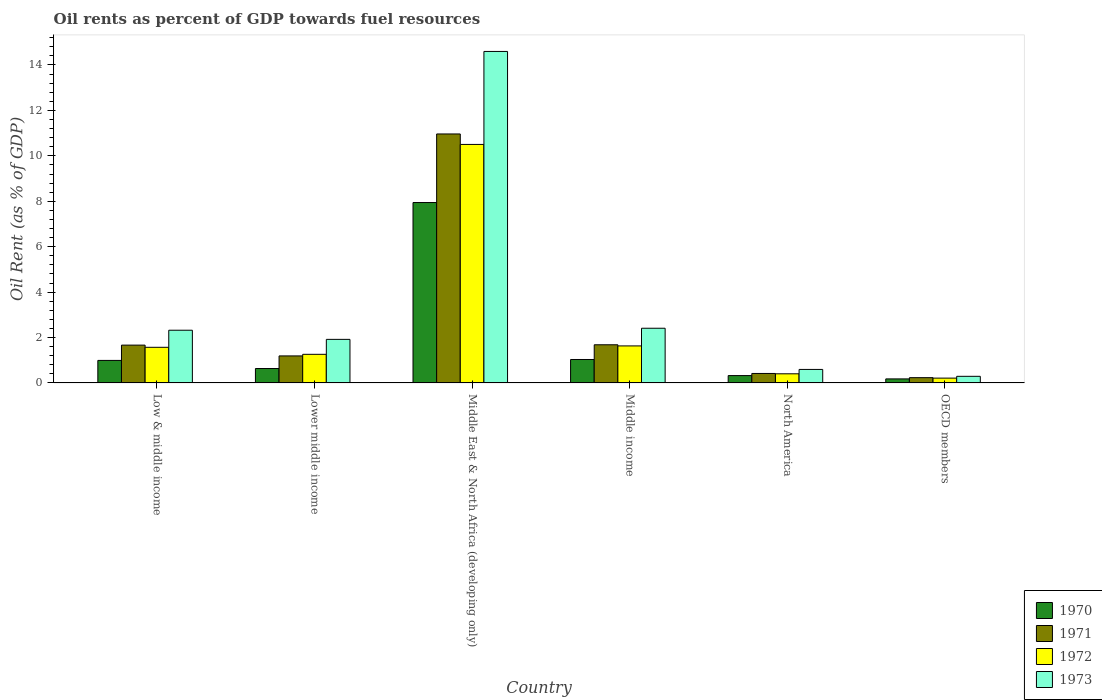How many different coloured bars are there?
Provide a short and direct response. 4. How many groups of bars are there?
Ensure brevity in your answer.  6. Are the number of bars on each tick of the X-axis equal?
Make the answer very short. Yes. How many bars are there on the 6th tick from the right?
Your answer should be very brief. 4. In how many cases, is the number of bars for a given country not equal to the number of legend labels?
Make the answer very short. 0. What is the oil rent in 1972 in Lower middle income?
Give a very brief answer. 1.26. Across all countries, what is the maximum oil rent in 1973?
Ensure brevity in your answer.  14.6. Across all countries, what is the minimum oil rent in 1972?
Offer a very short reply. 0.21. In which country was the oil rent in 1971 maximum?
Ensure brevity in your answer.  Middle East & North Africa (developing only). In which country was the oil rent in 1972 minimum?
Your answer should be compact. OECD members. What is the total oil rent in 1973 in the graph?
Keep it short and to the point. 22.13. What is the difference between the oil rent in 1972 in Low & middle income and that in Lower middle income?
Offer a terse response. 0.31. What is the difference between the oil rent in 1973 in Middle East & North Africa (developing only) and the oil rent in 1972 in OECD members?
Give a very brief answer. 14.38. What is the average oil rent in 1972 per country?
Your response must be concise. 2.6. What is the difference between the oil rent of/in 1973 and oil rent of/in 1972 in Middle East & North Africa (developing only)?
Offer a very short reply. 4.09. In how many countries, is the oil rent in 1972 greater than 14 %?
Provide a succinct answer. 0. What is the ratio of the oil rent in 1970 in Middle income to that in North America?
Your answer should be compact. 3.19. Is the oil rent in 1973 in Low & middle income less than that in OECD members?
Provide a short and direct response. No. What is the difference between the highest and the second highest oil rent in 1970?
Ensure brevity in your answer.  -0.04. What is the difference between the highest and the lowest oil rent in 1972?
Provide a short and direct response. 10.29. In how many countries, is the oil rent in 1972 greater than the average oil rent in 1972 taken over all countries?
Your answer should be very brief. 1. Is the sum of the oil rent in 1971 in Low & middle income and Lower middle income greater than the maximum oil rent in 1970 across all countries?
Provide a short and direct response. No. What does the 1st bar from the left in North America represents?
Ensure brevity in your answer.  1970. What does the 2nd bar from the right in Low & middle income represents?
Give a very brief answer. 1972. How many countries are there in the graph?
Give a very brief answer. 6. What is the difference between two consecutive major ticks on the Y-axis?
Keep it short and to the point. 2. Does the graph contain any zero values?
Make the answer very short. No. What is the title of the graph?
Provide a short and direct response. Oil rents as percent of GDP towards fuel resources. Does "1975" appear as one of the legend labels in the graph?
Offer a very short reply. No. What is the label or title of the X-axis?
Provide a succinct answer. Country. What is the label or title of the Y-axis?
Offer a very short reply. Oil Rent (as % of GDP). What is the Oil Rent (as % of GDP) in 1970 in Low & middle income?
Make the answer very short. 0.99. What is the Oil Rent (as % of GDP) of 1971 in Low & middle income?
Offer a very short reply. 1.67. What is the Oil Rent (as % of GDP) in 1972 in Low & middle income?
Offer a very short reply. 1.57. What is the Oil Rent (as % of GDP) of 1973 in Low & middle income?
Provide a short and direct response. 2.32. What is the Oil Rent (as % of GDP) in 1970 in Lower middle income?
Provide a short and direct response. 0.63. What is the Oil Rent (as % of GDP) of 1971 in Lower middle income?
Your response must be concise. 1.19. What is the Oil Rent (as % of GDP) in 1972 in Lower middle income?
Provide a short and direct response. 1.26. What is the Oil Rent (as % of GDP) in 1973 in Lower middle income?
Ensure brevity in your answer.  1.92. What is the Oil Rent (as % of GDP) in 1970 in Middle East & North Africa (developing only)?
Make the answer very short. 7.94. What is the Oil Rent (as % of GDP) in 1971 in Middle East & North Africa (developing only)?
Ensure brevity in your answer.  10.96. What is the Oil Rent (as % of GDP) in 1972 in Middle East & North Africa (developing only)?
Your answer should be very brief. 10.5. What is the Oil Rent (as % of GDP) of 1973 in Middle East & North Africa (developing only)?
Give a very brief answer. 14.6. What is the Oil Rent (as % of GDP) in 1970 in Middle income?
Ensure brevity in your answer.  1.03. What is the Oil Rent (as % of GDP) of 1971 in Middle income?
Keep it short and to the point. 1.68. What is the Oil Rent (as % of GDP) in 1972 in Middle income?
Ensure brevity in your answer.  1.63. What is the Oil Rent (as % of GDP) of 1973 in Middle income?
Offer a terse response. 2.41. What is the Oil Rent (as % of GDP) of 1970 in North America?
Make the answer very short. 0.32. What is the Oil Rent (as % of GDP) in 1971 in North America?
Provide a succinct answer. 0.42. What is the Oil Rent (as % of GDP) of 1972 in North America?
Make the answer very short. 0.4. What is the Oil Rent (as % of GDP) in 1973 in North America?
Offer a terse response. 0.6. What is the Oil Rent (as % of GDP) in 1970 in OECD members?
Your response must be concise. 0.18. What is the Oil Rent (as % of GDP) in 1971 in OECD members?
Your answer should be very brief. 0.23. What is the Oil Rent (as % of GDP) of 1972 in OECD members?
Make the answer very short. 0.21. What is the Oil Rent (as % of GDP) in 1973 in OECD members?
Give a very brief answer. 0.29. Across all countries, what is the maximum Oil Rent (as % of GDP) in 1970?
Offer a terse response. 7.94. Across all countries, what is the maximum Oil Rent (as % of GDP) in 1971?
Keep it short and to the point. 10.96. Across all countries, what is the maximum Oil Rent (as % of GDP) in 1972?
Your answer should be very brief. 10.5. Across all countries, what is the maximum Oil Rent (as % of GDP) in 1973?
Your response must be concise. 14.6. Across all countries, what is the minimum Oil Rent (as % of GDP) of 1970?
Provide a short and direct response. 0.18. Across all countries, what is the minimum Oil Rent (as % of GDP) of 1971?
Give a very brief answer. 0.23. Across all countries, what is the minimum Oil Rent (as % of GDP) of 1972?
Keep it short and to the point. 0.21. Across all countries, what is the minimum Oil Rent (as % of GDP) of 1973?
Provide a short and direct response. 0.29. What is the total Oil Rent (as % of GDP) in 1970 in the graph?
Provide a succinct answer. 11.1. What is the total Oil Rent (as % of GDP) of 1971 in the graph?
Provide a succinct answer. 16.15. What is the total Oil Rent (as % of GDP) in 1972 in the graph?
Ensure brevity in your answer.  15.58. What is the total Oil Rent (as % of GDP) of 1973 in the graph?
Give a very brief answer. 22.13. What is the difference between the Oil Rent (as % of GDP) in 1970 in Low & middle income and that in Lower middle income?
Your answer should be very brief. 0.36. What is the difference between the Oil Rent (as % of GDP) in 1971 in Low & middle income and that in Lower middle income?
Your answer should be compact. 0.48. What is the difference between the Oil Rent (as % of GDP) of 1972 in Low & middle income and that in Lower middle income?
Offer a terse response. 0.31. What is the difference between the Oil Rent (as % of GDP) of 1973 in Low & middle income and that in Lower middle income?
Your answer should be very brief. 0.4. What is the difference between the Oil Rent (as % of GDP) of 1970 in Low & middle income and that in Middle East & North Africa (developing only)?
Offer a terse response. -6.95. What is the difference between the Oil Rent (as % of GDP) of 1971 in Low & middle income and that in Middle East & North Africa (developing only)?
Keep it short and to the point. -9.3. What is the difference between the Oil Rent (as % of GDP) in 1972 in Low & middle income and that in Middle East & North Africa (developing only)?
Your response must be concise. -8.93. What is the difference between the Oil Rent (as % of GDP) of 1973 in Low & middle income and that in Middle East & North Africa (developing only)?
Give a very brief answer. -12.28. What is the difference between the Oil Rent (as % of GDP) in 1970 in Low & middle income and that in Middle income?
Provide a short and direct response. -0.04. What is the difference between the Oil Rent (as % of GDP) in 1971 in Low & middle income and that in Middle income?
Provide a succinct answer. -0.01. What is the difference between the Oil Rent (as % of GDP) in 1972 in Low & middle income and that in Middle income?
Make the answer very short. -0.06. What is the difference between the Oil Rent (as % of GDP) in 1973 in Low & middle income and that in Middle income?
Provide a short and direct response. -0.09. What is the difference between the Oil Rent (as % of GDP) of 1970 in Low & middle income and that in North America?
Your response must be concise. 0.67. What is the difference between the Oil Rent (as % of GDP) of 1971 in Low & middle income and that in North America?
Keep it short and to the point. 1.25. What is the difference between the Oil Rent (as % of GDP) of 1972 in Low & middle income and that in North America?
Give a very brief answer. 1.17. What is the difference between the Oil Rent (as % of GDP) of 1973 in Low & middle income and that in North America?
Offer a terse response. 1.73. What is the difference between the Oil Rent (as % of GDP) in 1970 in Low & middle income and that in OECD members?
Offer a terse response. 0.81. What is the difference between the Oil Rent (as % of GDP) of 1971 in Low & middle income and that in OECD members?
Make the answer very short. 1.43. What is the difference between the Oil Rent (as % of GDP) in 1972 in Low & middle income and that in OECD members?
Provide a short and direct response. 1.36. What is the difference between the Oil Rent (as % of GDP) in 1973 in Low & middle income and that in OECD members?
Ensure brevity in your answer.  2.03. What is the difference between the Oil Rent (as % of GDP) in 1970 in Lower middle income and that in Middle East & North Africa (developing only)?
Your response must be concise. -7.31. What is the difference between the Oil Rent (as % of GDP) in 1971 in Lower middle income and that in Middle East & North Africa (developing only)?
Give a very brief answer. -9.77. What is the difference between the Oil Rent (as % of GDP) of 1972 in Lower middle income and that in Middle East & North Africa (developing only)?
Provide a short and direct response. -9.24. What is the difference between the Oil Rent (as % of GDP) of 1973 in Lower middle income and that in Middle East & North Africa (developing only)?
Offer a terse response. -12.68. What is the difference between the Oil Rent (as % of GDP) in 1970 in Lower middle income and that in Middle income?
Provide a succinct answer. -0.4. What is the difference between the Oil Rent (as % of GDP) in 1971 in Lower middle income and that in Middle income?
Ensure brevity in your answer.  -0.49. What is the difference between the Oil Rent (as % of GDP) of 1972 in Lower middle income and that in Middle income?
Ensure brevity in your answer.  -0.37. What is the difference between the Oil Rent (as % of GDP) in 1973 in Lower middle income and that in Middle income?
Offer a terse response. -0.49. What is the difference between the Oil Rent (as % of GDP) in 1970 in Lower middle income and that in North America?
Your answer should be compact. 0.31. What is the difference between the Oil Rent (as % of GDP) in 1971 in Lower middle income and that in North America?
Ensure brevity in your answer.  0.77. What is the difference between the Oil Rent (as % of GDP) in 1972 in Lower middle income and that in North America?
Your answer should be compact. 0.86. What is the difference between the Oil Rent (as % of GDP) of 1973 in Lower middle income and that in North America?
Give a very brief answer. 1.32. What is the difference between the Oil Rent (as % of GDP) of 1970 in Lower middle income and that in OECD members?
Give a very brief answer. 0.46. What is the difference between the Oil Rent (as % of GDP) in 1971 in Lower middle income and that in OECD members?
Give a very brief answer. 0.96. What is the difference between the Oil Rent (as % of GDP) in 1972 in Lower middle income and that in OECD members?
Keep it short and to the point. 1.05. What is the difference between the Oil Rent (as % of GDP) in 1973 in Lower middle income and that in OECD members?
Your answer should be compact. 1.63. What is the difference between the Oil Rent (as % of GDP) of 1970 in Middle East & North Africa (developing only) and that in Middle income?
Your answer should be very brief. 6.91. What is the difference between the Oil Rent (as % of GDP) of 1971 in Middle East & North Africa (developing only) and that in Middle income?
Provide a succinct answer. 9.28. What is the difference between the Oil Rent (as % of GDP) of 1972 in Middle East & North Africa (developing only) and that in Middle income?
Your answer should be compact. 8.87. What is the difference between the Oil Rent (as % of GDP) in 1973 in Middle East & North Africa (developing only) and that in Middle income?
Offer a terse response. 12.19. What is the difference between the Oil Rent (as % of GDP) in 1970 in Middle East & North Africa (developing only) and that in North America?
Offer a very short reply. 7.62. What is the difference between the Oil Rent (as % of GDP) in 1971 in Middle East & North Africa (developing only) and that in North America?
Offer a very short reply. 10.55. What is the difference between the Oil Rent (as % of GDP) in 1972 in Middle East & North Africa (developing only) and that in North America?
Ensure brevity in your answer.  10.1. What is the difference between the Oil Rent (as % of GDP) in 1973 in Middle East & North Africa (developing only) and that in North America?
Ensure brevity in your answer.  14. What is the difference between the Oil Rent (as % of GDP) in 1970 in Middle East & North Africa (developing only) and that in OECD members?
Your answer should be very brief. 7.77. What is the difference between the Oil Rent (as % of GDP) of 1971 in Middle East & North Africa (developing only) and that in OECD members?
Offer a very short reply. 10.73. What is the difference between the Oil Rent (as % of GDP) of 1972 in Middle East & North Africa (developing only) and that in OECD members?
Provide a succinct answer. 10.29. What is the difference between the Oil Rent (as % of GDP) in 1973 in Middle East & North Africa (developing only) and that in OECD members?
Ensure brevity in your answer.  14.3. What is the difference between the Oil Rent (as % of GDP) in 1970 in Middle income and that in North America?
Your response must be concise. 0.71. What is the difference between the Oil Rent (as % of GDP) of 1971 in Middle income and that in North America?
Keep it short and to the point. 1.26. What is the difference between the Oil Rent (as % of GDP) of 1972 in Middle income and that in North America?
Offer a very short reply. 1.23. What is the difference between the Oil Rent (as % of GDP) in 1973 in Middle income and that in North America?
Keep it short and to the point. 1.81. What is the difference between the Oil Rent (as % of GDP) of 1970 in Middle income and that in OECD members?
Your answer should be compact. 0.85. What is the difference between the Oil Rent (as % of GDP) in 1971 in Middle income and that in OECD members?
Provide a short and direct response. 1.45. What is the difference between the Oil Rent (as % of GDP) of 1972 in Middle income and that in OECD members?
Your response must be concise. 1.42. What is the difference between the Oil Rent (as % of GDP) of 1973 in Middle income and that in OECD members?
Your response must be concise. 2.12. What is the difference between the Oil Rent (as % of GDP) in 1970 in North America and that in OECD members?
Your answer should be compact. 0.15. What is the difference between the Oil Rent (as % of GDP) in 1971 in North America and that in OECD members?
Make the answer very short. 0.18. What is the difference between the Oil Rent (as % of GDP) of 1972 in North America and that in OECD members?
Provide a succinct answer. 0.19. What is the difference between the Oil Rent (as % of GDP) of 1973 in North America and that in OECD members?
Give a very brief answer. 0.3. What is the difference between the Oil Rent (as % of GDP) in 1970 in Low & middle income and the Oil Rent (as % of GDP) in 1971 in Lower middle income?
Make the answer very short. -0.2. What is the difference between the Oil Rent (as % of GDP) of 1970 in Low & middle income and the Oil Rent (as % of GDP) of 1972 in Lower middle income?
Ensure brevity in your answer.  -0.27. What is the difference between the Oil Rent (as % of GDP) of 1970 in Low & middle income and the Oil Rent (as % of GDP) of 1973 in Lower middle income?
Make the answer very short. -0.93. What is the difference between the Oil Rent (as % of GDP) in 1971 in Low & middle income and the Oil Rent (as % of GDP) in 1972 in Lower middle income?
Provide a succinct answer. 0.41. What is the difference between the Oil Rent (as % of GDP) of 1971 in Low & middle income and the Oil Rent (as % of GDP) of 1973 in Lower middle income?
Give a very brief answer. -0.25. What is the difference between the Oil Rent (as % of GDP) in 1972 in Low & middle income and the Oil Rent (as % of GDP) in 1973 in Lower middle income?
Make the answer very short. -0.35. What is the difference between the Oil Rent (as % of GDP) of 1970 in Low & middle income and the Oil Rent (as % of GDP) of 1971 in Middle East & North Africa (developing only)?
Offer a terse response. -9.97. What is the difference between the Oil Rent (as % of GDP) of 1970 in Low & middle income and the Oil Rent (as % of GDP) of 1972 in Middle East & North Africa (developing only)?
Provide a succinct answer. -9.51. What is the difference between the Oil Rent (as % of GDP) in 1970 in Low & middle income and the Oil Rent (as % of GDP) in 1973 in Middle East & North Africa (developing only)?
Your response must be concise. -13.6. What is the difference between the Oil Rent (as % of GDP) of 1971 in Low & middle income and the Oil Rent (as % of GDP) of 1972 in Middle East & North Africa (developing only)?
Offer a very short reply. -8.84. What is the difference between the Oil Rent (as % of GDP) of 1971 in Low & middle income and the Oil Rent (as % of GDP) of 1973 in Middle East & North Africa (developing only)?
Keep it short and to the point. -12.93. What is the difference between the Oil Rent (as % of GDP) in 1972 in Low & middle income and the Oil Rent (as % of GDP) in 1973 in Middle East & North Africa (developing only)?
Provide a short and direct response. -13.03. What is the difference between the Oil Rent (as % of GDP) of 1970 in Low & middle income and the Oil Rent (as % of GDP) of 1971 in Middle income?
Give a very brief answer. -0.69. What is the difference between the Oil Rent (as % of GDP) in 1970 in Low & middle income and the Oil Rent (as % of GDP) in 1972 in Middle income?
Provide a succinct answer. -0.64. What is the difference between the Oil Rent (as % of GDP) of 1970 in Low & middle income and the Oil Rent (as % of GDP) of 1973 in Middle income?
Ensure brevity in your answer.  -1.42. What is the difference between the Oil Rent (as % of GDP) in 1971 in Low & middle income and the Oil Rent (as % of GDP) in 1972 in Middle income?
Your response must be concise. 0.03. What is the difference between the Oil Rent (as % of GDP) of 1971 in Low & middle income and the Oil Rent (as % of GDP) of 1973 in Middle income?
Offer a terse response. -0.74. What is the difference between the Oil Rent (as % of GDP) of 1972 in Low & middle income and the Oil Rent (as % of GDP) of 1973 in Middle income?
Ensure brevity in your answer.  -0.84. What is the difference between the Oil Rent (as % of GDP) of 1970 in Low & middle income and the Oil Rent (as % of GDP) of 1971 in North America?
Give a very brief answer. 0.57. What is the difference between the Oil Rent (as % of GDP) of 1970 in Low & middle income and the Oil Rent (as % of GDP) of 1972 in North America?
Keep it short and to the point. 0.59. What is the difference between the Oil Rent (as % of GDP) of 1970 in Low & middle income and the Oil Rent (as % of GDP) of 1973 in North America?
Provide a succinct answer. 0.4. What is the difference between the Oil Rent (as % of GDP) of 1971 in Low & middle income and the Oil Rent (as % of GDP) of 1972 in North America?
Your answer should be very brief. 1.26. What is the difference between the Oil Rent (as % of GDP) in 1971 in Low & middle income and the Oil Rent (as % of GDP) in 1973 in North America?
Give a very brief answer. 1.07. What is the difference between the Oil Rent (as % of GDP) of 1972 in Low & middle income and the Oil Rent (as % of GDP) of 1973 in North America?
Give a very brief answer. 0.97. What is the difference between the Oil Rent (as % of GDP) in 1970 in Low & middle income and the Oil Rent (as % of GDP) in 1971 in OECD members?
Make the answer very short. 0.76. What is the difference between the Oil Rent (as % of GDP) of 1970 in Low & middle income and the Oil Rent (as % of GDP) of 1972 in OECD members?
Give a very brief answer. 0.78. What is the difference between the Oil Rent (as % of GDP) of 1970 in Low & middle income and the Oil Rent (as % of GDP) of 1973 in OECD members?
Give a very brief answer. 0.7. What is the difference between the Oil Rent (as % of GDP) in 1971 in Low & middle income and the Oil Rent (as % of GDP) in 1972 in OECD members?
Ensure brevity in your answer.  1.45. What is the difference between the Oil Rent (as % of GDP) of 1971 in Low & middle income and the Oil Rent (as % of GDP) of 1973 in OECD members?
Offer a terse response. 1.37. What is the difference between the Oil Rent (as % of GDP) in 1972 in Low & middle income and the Oil Rent (as % of GDP) in 1973 in OECD members?
Offer a terse response. 1.28. What is the difference between the Oil Rent (as % of GDP) of 1970 in Lower middle income and the Oil Rent (as % of GDP) of 1971 in Middle East & North Africa (developing only)?
Give a very brief answer. -10.33. What is the difference between the Oil Rent (as % of GDP) of 1970 in Lower middle income and the Oil Rent (as % of GDP) of 1972 in Middle East & North Africa (developing only)?
Your answer should be compact. -9.87. What is the difference between the Oil Rent (as % of GDP) of 1970 in Lower middle income and the Oil Rent (as % of GDP) of 1973 in Middle East & North Africa (developing only)?
Provide a succinct answer. -13.96. What is the difference between the Oil Rent (as % of GDP) in 1971 in Lower middle income and the Oil Rent (as % of GDP) in 1972 in Middle East & North Africa (developing only)?
Provide a short and direct response. -9.31. What is the difference between the Oil Rent (as % of GDP) in 1971 in Lower middle income and the Oil Rent (as % of GDP) in 1973 in Middle East & North Africa (developing only)?
Your answer should be compact. -13.41. What is the difference between the Oil Rent (as % of GDP) of 1972 in Lower middle income and the Oil Rent (as % of GDP) of 1973 in Middle East & North Africa (developing only)?
Provide a short and direct response. -13.34. What is the difference between the Oil Rent (as % of GDP) of 1970 in Lower middle income and the Oil Rent (as % of GDP) of 1971 in Middle income?
Give a very brief answer. -1.05. What is the difference between the Oil Rent (as % of GDP) of 1970 in Lower middle income and the Oil Rent (as % of GDP) of 1972 in Middle income?
Give a very brief answer. -1. What is the difference between the Oil Rent (as % of GDP) of 1970 in Lower middle income and the Oil Rent (as % of GDP) of 1973 in Middle income?
Your answer should be very brief. -1.77. What is the difference between the Oil Rent (as % of GDP) of 1971 in Lower middle income and the Oil Rent (as % of GDP) of 1972 in Middle income?
Your answer should be compact. -0.44. What is the difference between the Oil Rent (as % of GDP) of 1971 in Lower middle income and the Oil Rent (as % of GDP) of 1973 in Middle income?
Make the answer very short. -1.22. What is the difference between the Oil Rent (as % of GDP) of 1972 in Lower middle income and the Oil Rent (as % of GDP) of 1973 in Middle income?
Offer a very short reply. -1.15. What is the difference between the Oil Rent (as % of GDP) in 1970 in Lower middle income and the Oil Rent (as % of GDP) in 1971 in North America?
Your answer should be very brief. 0.22. What is the difference between the Oil Rent (as % of GDP) of 1970 in Lower middle income and the Oil Rent (as % of GDP) of 1972 in North America?
Give a very brief answer. 0.23. What is the difference between the Oil Rent (as % of GDP) in 1970 in Lower middle income and the Oil Rent (as % of GDP) in 1973 in North America?
Ensure brevity in your answer.  0.04. What is the difference between the Oil Rent (as % of GDP) in 1971 in Lower middle income and the Oil Rent (as % of GDP) in 1972 in North America?
Your answer should be compact. 0.79. What is the difference between the Oil Rent (as % of GDP) in 1971 in Lower middle income and the Oil Rent (as % of GDP) in 1973 in North America?
Provide a short and direct response. 0.6. What is the difference between the Oil Rent (as % of GDP) of 1972 in Lower middle income and the Oil Rent (as % of GDP) of 1973 in North America?
Your answer should be very brief. 0.66. What is the difference between the Oil Rent (as % of GDP) in 1970 in Lower middle income and the Oil Rent (as % of GDP) in 1971 in OECD members?
Keep it short and to the point. 0.4. What is the difference between the Oil Rent (as % of GDP) of 1970 in Lower middle income and the Oil Rent (as % of GDP) of 1972 in OECD members?
Your answer should be very brief. 0.42. What is the difference between the Oil Rent (as % of GDP) in 1970 in Lower middle income and the Oil Rent (as % of GDP) in 1973 in OECD members?
Make the answer very short. 0.34. What is the difference between the Oil Rent (as % of GDP) in 1971 in Lower middle income and the Oil Rent (as % of GDP) in 1972 in OECD members?
Give a very brief answer. 0.98. What is the difference between the Oil Rent (as % of GDP) of 1971 in Lower middle income and the Oil Rent (as % of GDP) of 1973 in OECD members?
Offer a very short reply. 0.9. What is the difference between the Oil Rent (as % of GDP) of 1972 in Lower middle income and the Oil Rent (as % of GDP) of 1973 in OECD members?
Give a very brief answer. 0.97. What is the difference between the Oil Rent (as % of GDP) of 1970 in Middle East & North Africa (developing only) and the Oil Rent (as % of GDP) of 1971 in Middle income?
Ensure brevity in your answer.  6.26. What is the difference between the Oil Rent (as % of GDP) in 1970 in Middle East & North Africa (developing only) and the Oil Rent (as % of GDP) in 1972 in Middle income?
Give a very brief answer. 6.31. What is the difference between the Oil Rent (as % of GDP) in 1970 in Middle East & North Africa (developing only) and the Oil Rent (as % of GDP) in 1973 in Middle income?
Your answer should be compact. 5.53. What is the difference between the Oil Rent (as % of GDP) of 1971 in Middle East & North Africa (developing only) and the Oil Rent (as % of GDP) of 1972 in Middle income?
Your answer should be compact. 9.33. What is the difference between the Oil Rent (as % of GDP) in 1971 in Middle East & North Africa (developing only) and the Oil Rent (as % of GDP) in 1973 in Middle income?
Offer a very short reply. 8.55. What is the difference between the Oil Rent (as % of GDP) of 1972 in Middle East & North Africa (developing only) and the Oil Rent (as % of GDP) of 1973 in Middle income?
Your answer should be very brief. 8.09. What is the difference between the Oil Rent (as % of GDP) of 1970 in Middle East & North Africa (developing only) and the Oil Rent (as % of GDP) of 1971 in North America?
Provide a short and direct response. 7.53. What is the difference between the Oil Rent (as % of GDP) in 1970 in Middle East & North Africa (developing only) and the Oil Rent (as % of GDP) in 1972 in North America?
Offer a terse response. 7.54. What is the difference between the Oil Rent (as % of GDP) in 1970 in Middle East & North Africa (developing only) and the Oil Rent (as % of GDP) in 1973 in North America?
Your answer should be very brief. 7.35. What is the difference between the Oil Rent (as % of GDP) of 1971 in Middle East & North Africa (developing only) and the Oil Rent (as % of GDP) of 1972 in North America?
Your answer should be compact. 10.56. What is the difference between the Oil Rent (as % of GDP) of 1971 in Middle East & North Africa (developing only) and the Oil Rent (as % of GDP) of 1973 in North America?
Offer a terse response. 10.37. What is the difference between the Oil Rent (as % of GDP) in 1972 in Middle East & North Africa (developing only) and the Oil Rent (as % of GDP) in 1973 in North America?
Give a very brief answer. 9.91. What is the difference between the Oil Rent (as % of GDP) of 1970 in Middle East & North Africa (developing only) and the Oil Rent (as % of GDP) of 1971 in OECD members?
Offer a terse response. 7.71. What is the difference between the Oil Rent (as % of GDP) in 1970 in Middle East & North Africa (developing only) and the Oil Rent (as % of GDP) in 1972 in OECD members?
Ensure brevity in your answer.  7.73. What is the difference between the Oil Rent (as % of GDP) in 1970 in Middle East & North Africa (developing only) and the Oil Rent (as % of GDP) in 1973 in OECD members?
Offer a very short reply. 7.65. What is the difference between the Oil Rent (as % of GDP) in 1971 in Middle East & North Africa (developing only) and the Oil Rent (as % of GDP) in 1972 in OECD members?
Your response must be concise. 10.75. What is the difference between the Oil Rent (as % of GDP) of 1971 in Middle East & North Africa (developing only) and the Oil Rent (as % of GDP) of 1973 in OECD members?
Provide a succinct answer. 10.67. What is the difference between the Oil Rent (as % of GDP) in 1972 in Middle East & North Africa (developing only) and the Oil Rent (as % of GDP) in 1973 in OECD members?
Make the answer very short. 10.21. What is the difference between the Oil Rent (as % of GDP) in 1970 in Middle income and the Oil Rent (as % of GDP) in 1971 in North America?
Offer a very short reply. 0.61. What is the difference between the Oil Rent (as % of GDP) in 1970 in Middle income and the Oil Rent (as % of GDP) in 1972 in North America?
Give a very brief answer. 0.63. What is the difference between the Oil Rent (as % of GDP) in 1970 in Middle income and the Oil Rent (as % of GDP) in 1973 in North America?
Your response must be concise. 0.44. What is the difference between the Oil Rent (as % of GDP) in 1971 in Middle income and the Oil Rent (as % of GDP) in 1972 in North America?
Offer a terse response. 1.28. What is the difference between the Oil Rent (as % of GDP) in 1971 in Middle income and the Oil Rent (as % of GDP) in 1973 in North America?
Your response must be concise. 1.09. What is the difference between the Oil Rent (as % of GDP) in 1972 in Middle income and the Oil Rent (as % of GDP) in 1973 in North America?
Offer a very short reply. 1.04. What is the difference between the Oil Rent (as % of GDP) in 1970 in Middle income and the Oil Rent (as % of GDP) in 1971 in OECD members?
Provide a succinct answer. 0.8. What is the difference between the Oil Rent (as % of GDP) in 1970 in Middle income and the Oil Rent (as % of GDP) in 1972 in OECD members?
Provide a short and direct response. 0.82. What is the difference between the Oil Rent (as % of GDP) of 1970 in Middle income and the Oil Rent (as % of GDP) of 1973 in OECD members?
Keep it short and to the point. 0.74. What is the difference between the Oil Rent (as % of GDP) in 1971 in Middle income and the Oil Rent (as % of GDP) in 1972 in OECD members?
Provide a succinct answer. 1.47. What is the difference between the Oil Rent (as % of GDP) of 1971 in Middle income and the Oil Rent (as % of GDP) of 1973 in OECD members?
Make the answer very short. 1.39. What is the difference between the Oil Rent (as % of GDP) in 1972 in Middle income and the Oil Rent (as % of GDP) in 1973 in OECD members?
Provide a short and direct response. 1.34. What is the difference between the Oil Rent (as % of GDP) in 1970 in North America and the Oil Rent (as % of GDP) in 1971 in OECD members?
Your answer should be compact. 0.09. What is the difference between the Oil Rent (as % of GDP) in 1970 in North America and the Oil Rent (as % of GDP) in 1972 in OECD members?
Offer a very short reply. 0.11. What is the difference between the Oil Rent (as % of GDP) in 1970 in North America and the Oil Rent (as % of GDP) in 1973 in OECD members?
Your response must be concise. 0.03. What is the difference between the Oil Rent (as % of GDP) in 1971 in North America and the Oil Rent (as % of GDP) in 1972 in OECD members?
Keep it short and to the point. 0.21. What is the difference between the Oil Rent (as % of GDP) of 1971 in North America and the Oil Rent (as % of GDP) of 1973 in OECD members?
Give a very brief answer. 0.13. What is the difference between the Oil Rent (as % of GDP) in 1972 in North America and the Oil Rent (as % of GDP) in 1973 in OECD members?
Give a very brief answer. 0.11. What is the average Oil Rent (as % of GDP) in 1970 per country?
Your answer should be compact. 1.85. What is the average Oil Rent (as % of GDP) in 1971 per country?
Keep it short and to the point. 2.69. What is the average Oil Rent (as % of GDP) in 1972 per country?
Provide a short and direct response. 2.6. What is the average Oil Rent (as % of GDP) of 1973 per country?
Your answer should be compact. 3.69. What is the difference between the Oil Rent (as % of GDP) in 1970 and Oil Rent (as % of GDP) in 1971 in Low & middle income?
Provide a short and direct response. -0.67. What is the difference between the Oil Rent (as % of GDP) of 1970 and Oil Rent (as % of GDP) of 1972 in Low & middle income?
Offer a terse response. -0.58. What is the difference between the Oil Rent (as % of GDP) of 1970 and Oil Rent (as % of GDP) of 1973 in Low & middle income?
Your answer should be compact. -1.33. What is the difference between the Oil Rent (as % of GDP) of 1971 and Oil Rent (as % of GDP) of 1972 in Low & middle income?
Ensure brevity in your answer.  0.1. What is the difference between the Oil Rent (as % of GDP) in 1971 and Oil Rent (as % of GDP) in 1973 in Low & middle income?
Keep it short and to the point. -0.66. What is the difference between the Oil Rent (as % of GDP) in 1972 and Oil Rent (as % of GDP) in 1973 in Low & middle income?
Your answer should be very brief. -0.75. What is the difference between the Oil Rent (as % of GDP) of 1970 and Oil Rent (as % of GDP) of 1971 in Lower middle income?
Your answer should be very brief. -0.56. What is the difference between the Oil Rent (as % of GDP) of 1970 and Oil Rent (as % of GDP) of 1972 in Lower middle income?
Make the answer very short. -0.62. What is the difference between the Oil Rent (as % of GDP) in 1970 and Oil Rent (as % of GDP) in 1973 in Lower middle income?
Ensure brevity in your answer.  -1.28. What is the difference between the Oil Rent (as % of GDP) of 1971 and Oil Rent (as % of GDP) of 1972 in Lower middle income?
Offer a very short reply. -0.07. What is the difference between the Oil Rent (as % of GDP) in 1971 and Oil Rent (as % of GDP) in 1973 in Lower middle income?
Your answer should be very brief. -0.73. What is the difference between the Oil Rent (as % of GDP) of 1972 and Oil Rent (as % of GDP) of 1973 in Lower middle income?
Your answer should be compact. -0.66. What is the difference between the Oil Rent (as % of GDP) in 1970 and Oil Rent (as % of GDP) in 1971 in Middle East & North Africa (developing only)?
Keep it short and to the point. -3.02. What is the difference between the Oil Rent (as % of GDP) in 1970 and Oil Rent (as % of GDP) in 1972 in Middle East & North Africa (developing only)?
Give a very brief answer. -2.56. What is the difference between the Oil Rent (as % of GDP) of 1970 and Oil Rent (as % of GDP) of 1973 in Middle East & North Africa (developing only)?
Give a very brief answer. -6.65. What is the difference between the Oil Rent (as % of GDP) of 1971 and Oil Rent (as % of GDP) of 1972 in Middle East & North Africa (developing only)?
Make the answer very short. 0.46. What is the difference between the Oil Rent (as % of GDP) of 1971 and Oil Rent (as % of GDP) of 1973 in Middle East & North Africa (developing only)?
Give a very brief answer. -3.63. What is the difference between the Oil Rent (as % of GDP) of 1972 and Oil Rent (as % of GDP) of 1973 in Middle East & North Africa (developing only)?
Give a very brief answer. -4.09. What is the difference between the Oil Rent (as % of GDP) in 1970 and Oil Rent (as % of GDP) in 1971 in Middle income?
Make the answer very short. -0.65. What is the difference between the Oil Rent (as % of GDP) of 1970 and Oil Rent (as % of GDP) of 1972 in Middle income?
Give a very brief answer. -0.6. What is the difference between the Oil Rent (as % of GDP) in 1970 and Oil Rent (as % of GDP) in 1973 in Middle income?
Provide a succinct answer. -1.38. What is the difference between the Oil Rent (as % of GDP) of 1971 and Oil Rent (as % of GDP) of 1972 in Middle income?
Your response must be concise. 0.05. What is the difference between the Oil Rent (as % of GDP) of 1971 and Oil Rent (as % of GDP) of 1973 in Middle income?
Your answer should be compact. -0.73. What is the difference between the Oil Rent (as % of GDP) of 1972 and Oil Rent (as % of GDP) of 1973 in Middle income?
Provide a short and direct response. -0.78. What is the difference between the Oil Rent (as % of GDP) of 1970 and Oil Rent (as % of GDP) of 1971 in North America?
Make the answer very short. -0.09. What is the difference between the Oil Rent (as % of GDP) of 1970 and Oil Rent (as % of GDP) of 1972 in North America?
Give a very brief answer. -0.08. What is the difference between the Oil Rent (as % of GDP) in 1970 and Oil Rent (as % of GDP) in 1973 in North America?
Your response must be concise. -0.27. What is the difference between the Oil Rent (as % of GDP) in 1971 and Oil Rent (as % of GDP) in 1972 in North America?
Make the answer very short. 0.02. What is the difference between the Oil Rent (as % of GDP) in 1971 and Oil Rent (as % of GDP) in 1973 in North America?
Offer a very short reply. -0.18. What is the difference between the Oil Rent (as % of GDP) of 1972 and Oil Rent (as % of GDP) of 1973 in North America?
Give a very brief answer. -0.19. What is the difference between the Oil Rent (as % of GDP) in 1970 and Oil Rent (as % of GDP) in 1971 in OECD members?
Provide a succinct answer. -0.05. What is the difference between the Oil Rent (as % of GDP) of 1970 and Oil Rent (as % of GDP) of 1972 in OECD members?
Offer a very short reply. -0.03. What is the difference between the Oil Rent (as % of GDP) of 1970 and Oil Rent (as % of GDP) of 1973 in OECD members?
Provide a succinct answer. -0.11. What is the difference between the Oil Rent (as % of GDP) of 1971 and Oil Rent (as % of GDP) of 1972 in OECD members?
Offer a terse response. 0.02. What is the difference between the Oil Rent (as % of GDP) in 1971 and Oil Rent (as % of GDP) in 1973 in OECD members?
Your answer should be very brief. -0.06. What is the difference between the Oil Rent (as % of GDP) of 1972 and Oil Rent (as % of GDP) of 1973 in OECD members?
Your response must be concise. -0.08. What is the ratio of the Oil Rent (as % of GDP) in 1970 in Low & middle income to that in Lower middle income?
Your response must be concise. 1.56. What is the ratio of the Oil Rent (as % of GDP) of 1971 in Low & middle income to that in Lower middle income?
Offer a terse response. 1.4. What is the ratio of the Oil Rent (as % of GDP) of 1972 in Low & middle income to that in Lower middle income?
Ensure brevity in your answer.  1.25. What is the ratio of the Oil Rent (as % of GDP) of 1973 in Low & middle income to that in Lower middle income?
Make the answer very short. 1.21. What is the ratio of the Oil Rent (as % of GDP) in 1970 in Low & middle income to that in Middle East & North Africa (developing only)?
Give a very brief answer. 0.12. What is the ratio of the Oil Rent (as % of GDP) of 1971 in Low & middle income to that in Middle East & North Africa (developing only)?
Ensure brevity in your answer.  0.15. What is the ratio of the Oil Rent (as % of GDP) of 1972 in Low & middle income to that in Middle East & North Africa (developing only)?
Offer a terse response. 0.15. What is the ratio of the Oil Rent (as % of GDP) in 1973 in Low & middle income to that in Middle East & North Africa (developing only)?
Offer a terse response. 0.16. What is the ratio of the Oil Rent (as % of GDP) of 1970 in Low & middle income to that in Middle income?
Your answer should be very brief. 0.96. What is the ratio of the Oil Rent (as % of GDP) in 1972 in Low & middle income to that in Middle income?
Keep it short and to the point. 0.96. What is the ratio of the Oil Rent (as % of GDP) of 1973 in Low & middle income to that in Middle income?
Make the answer very short. 0.96. What is the ratio of the Oil Rent (as % of GDP) in 1970 in Low & middle income to that in North America?
Offer a terse response. 3.07. What is the ratio of the Oil Rent (as % of GDP) of 1971 in Low & middle income to that in North America?
Make the answer very short. 3.99. What is the ratio of the Oil Rent (as % of GDP) of 1972 in Low & middle income to that in North America?
Give a very brief answer. 3.9. What is the ratio of the Oil Rent (as % of GDP) in 1973 in Low & middle income to that in North America?
Make the answer very short. 3.9. What is the ratio of the Oil Rent (as % of GDP) in 1970 in Low & middle income to that in OECD members?
Give a very brief answer. 5.58. What is the ratio of the Oil Rent (as % of GDP) in 1971 in Low & middle income to that in OECD members?
Keep it short and to the point. 7.16. What is the ratio of the Oil Rent (as % of GDP) of 1972 in Low & middle income to that in OECD members?
Offer a terse response. 7.39. What is the ratio of the Oil Rent (as % of GDP) of 1973 in Low & middle income to that in OECD members?
Offer a terse response. 7.96. What is the ratio of the Oil Rent (as % of GDP) of 1970 in Lower middle income to that in Middle East & North Africa (developing only)?
Your answer should be compact. 0.08. What is the ratio of the Oil Rent (as % of GDP) of 1971 in Lower middle income to that in Middle East & North Africa (developing only)?
Provide a short and direct response. 0.11. What is the ratio of the Oil Rent (as % of GDP) in 1972 in Lower middle income to that in Middle East & North Africa (developing only)?
Your response must be concise. 0.12. What is the ratio of the Oil Rent (as % of GDP) in 1973 in Lower middle income to that in Middle East & North Africa (developing only)?
Ensure brevity in your answer.  0.13. What is the ratio of the Oil Rent (as % of GDP) of 1970 in Lower middle income to that in Middle income?
Keep it short and to the point. 0.61. What is the ratio of the Oil Rent (as % of GDP) in 1971 in Lower middle income to that in Middle income?
Keep it short and to the point. 0.71. What is the ratio of the Oil Rent (as % of GDP) in 1972 in Lower middle income to that in Middle income?
Make the answer very short. 0.77. What is the ratio of the Oil Rent (as % of GDP) in 1973 in Lower middle income to that in Middle income?
Keep it short and to the point. 0.8. What is the ratio of the Oil Rent (as % of GDP) in 1970 in Lower middle income to that in North America?
Your answer should be very brief. 1.96. What is the ratio of the Oil Rent (as % of GDP) in 1971 in Lower middle income to that in North America?
Keep it short and to the point. 2.85. What is the ratio of the Oil Rent (as % of GDP) in 1972 in Lower middle income to that in North America?
Keep it short and to the point. 3.13. What is the ratio of the Oil Rent (as % of GDP) in 1973 in Lower middle income to that in North America?
Your response must be concise. 3.22. What is the ratio of the Oil Rent (as % of GDP) in 1970 in Lower middle income to that in OECD members?
Make the answer very short. 3.57. What is the ratio of the Oil Rent (as % of GDP) of 1971 in Lower middle income to that in OECD members?
Ensure brevity in your answer.  5.12. What is the ratio of the Oil Rent (as % of GDP) in 1972 in Lower middle income to that in OECD members?
Keep it short and to the point. 5.94. What is the ratio of the Oil Rent (as % of GDP) in 1973 in Lower middle income to that in OECD members?
Give a very brief answer. 6.58. What is the ratio of the Oil Rent (as % of GDP) of 1970 in Middle East & North Africa (developing only) to that in Middle income?
Provide a short and direct response. 7.69. What is the ratio of the Oil Rent (as % of GDP) in 1971 in Middle East & North Africa (developing only) to that in Middle income?
Your answer should be compact. 6.52. What is the ratio of the Oil Rent (as % of GDP) in 1972 in Middle East & North Africa (developing only) to that in Middle income?
Make the answer very short. 6.44. What is the ratio of the Oil Rent (as % of GDP) in 1973 in Middle East & North Africa (developing only) to that in Middle income?
Provide a succinct answer. 6.06. What is the ratio of the Oil Rent (as % of GDP) of 1970 in Middle East & North Africa (developing only) to that in North America?
Your answer should be compact. 24.54. What is the ratio of the Oil Rent (as % of GDP) of 1971 in Middle East & North Africa (developing only) to that in North America?
Offer a terse response. 26.26. What is the ratio of the Oil Rent (as % of GDP) of 1972 in Middle East & North Africa (developing only) to that in North America?
Your answer should be compact. 26.11. What is the ratio of the Oil Rent (as % of GDP) in 1973 in Middle East & North Africa (developing only) to that in North America?
Offer a very short reply. 24.53. What is the ratio of the Oil Rent (as % of GDP) of 1970 in Middle East & North Africa (developing only) to that in OECD members?
Give a very brief answer. 44.68. What is the ratio of the Oil Rent (as % of GDP) of 1971 in Middle East & North Africa (developing only) to that in OECD members?
Your response must be concise. 47.15. What is the ratio of the Oil Rent (as % of GDP) in 1972 in Middle East & North Africa (developing only) to that in OECD members?
Offer a very short reply. 49.49. What is the ratio of the Oil Rent (as % of GDP) of 1973 in Middle East & North Africa (developing only) to that in OECD members?
Offer a very short reply. 50.04. What is the ratio of the Oil Rent (as % of GDP) of 1970 in Middle income to that in North America?
Give a very brief answer. 3.19. What is the ratio of the Oil Rent (as % of GDP) of 1971 in Middle income to that in North America?
Offer a terse response. 4.03. What is the ratio of the Oil Rent (as % of GDP) of 1972 in Middle income to that in North America?
Offer a terse response. 4.05. What is the ratio of the Oil Rent (as % of GDP) of 1973 in Middle income to that in North America?
Your answer should be compact. 4.05. What is the ratio of the Oil Rent (as % of GDP) in 1970 in Middle income to that in OECD members?
Make the answer very short. 5.81. What is the ratio of the Oil Rent (as % of GDP) in 1971 in Middle income to that in OECD members?
Provide a short and direct response. 7.23. What is the ratio of the Oil Rent (as % of GDP) in 1972 in Middle income to that in OECD members?
Keep it short and to the point. 7.68. What is the ratio of the Oil Rent (as % of GDP) of 1973 in Middle income to that in OECD members?
Your answer should be compact. 8.26. What is the ratio of the Oil Rent (as % of GDP) in 1970 in North America to that in OECD members?
Make the answer very short. 1.82. What is the ratio of the Oil Rent (as % of GDP) of 1971 in North America to that in OECD members?
Ensure brevity in your answer.  1.8. What is the ratio of the Oil Rent (as % of GDP) in 1972 in North America to that in OECD members?
Your answer should be compact. 1.9. What is the ratio of the Oil Rent (as % of GDP) of 1973 in North America to that in OECD members?
Your answer should be compact. 2.04. What is the difference between the highest and the second highest Oil Rent (as % of GDP) in 1970?
Keep it short and to the point. 6.91. What is the difference between the highest and the second highest Oil Rent (as % of GDP) in 1971?
Provide a short and direct response. 9.28. What is the difference between the highest and the second highest Oil Rent (as % of GDP) in 1972?
Your answer should be compact. 8.87. What is the difference between the highest and the second highest Oil Rent (as % of GDP) in 1973?
Your response must be concise. 12.19. What is the difference between the highest and the lowest Oil Rent (as % of GDP) of 1970?
Your response must be concise. 7.77. What is the difference between the highest and the lowest Oil Rent (as % of GDP) in 1971?
Provide a short and direct response. 10.73. What is the difference between the highest and the lowest Oil Rent (as % of GDP) of 1972?
Keep it short and to the point. 10.29. What is the difference between the highest and the lowest Oil Rent (as % of GDP) in 1973?
Your answer should be compact. 14.3. 